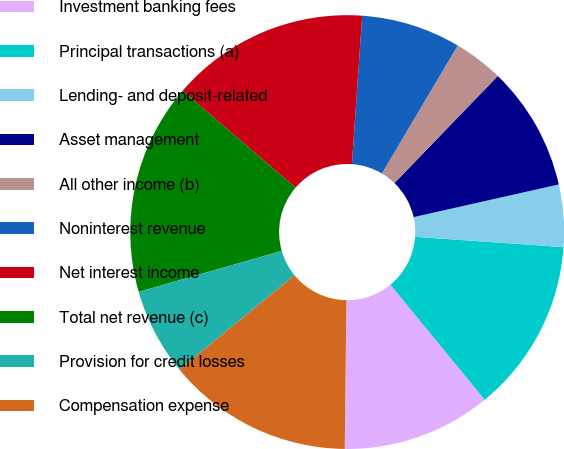<chart> <loc_0><loc_0><loc_500><loc_500><pie_chart><fcel>Investment banking fees<fcel>Principal transactions (a)<fcel>Lending- and deposit-related<fcel>Asset management<fcel>All other income (b)<fcel>Noninterest revenue<fcel>Net interest income<fcel>Total net revenue (c)<fcel>Provision for credit losses<fcel>Compensation expense<nl><fcel>11.11%<fcel>12.96%<fcel>4.63%<fcel>9.26%<fcel>3.7%<fcel>7.41%<fcel>14.81%<fcel>15.74%<fcel>6.48%<fcel>13.89%<nl></chart> 